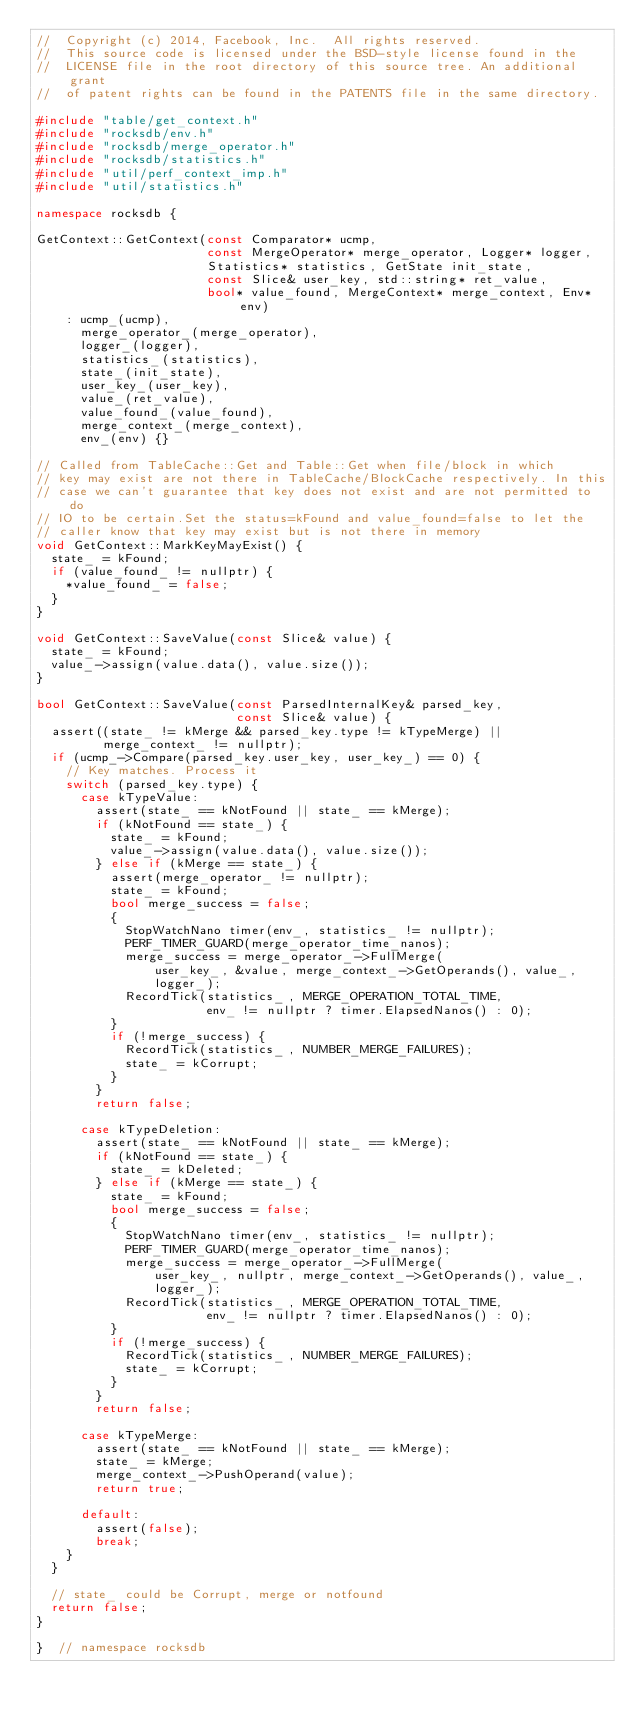Convert code to text. <code><loc_0><loc_0><loc_500><loc_500><_C++_>//  Copyright (c) 2014, Facebook, Inc.  All rights reserved.
//  This source code is licensed under the BSD-style license found in the
//  LICENSE file in the root directory of this source tree. An additional grant
//  of patent rights can be found in the PATENTS file in the same directory.

#include "table/get_context.h"
#include "rocksdb/env.h"
#include "rocksdb/merge_operator.h"
#include "rocksdb/statistics.h"
#include "util/perf_context_imp.h"
#include "util/statistics.h"

namespace rocksdb {

GetContext::GetContext(const Comparator* ucmp,
                       const MergeOperator* merge_operator, Logger* logger,
                       Statistics* statistics, GetState init_state,
                       const Slice& user_key, std::string* ret_value,
                       bool* value_found, MergeContext* merge_context, Env* env)
    : ucmp_(ucmp),
      merge_operator_(merge_operator),
      logger_(logger),
      statistics_(statistics),
      state_(init_state),
      user_key_(user_key),
      value_(ret_value),
      value_found_(value_found),
      merge_context_(merge_context),
      env_(env) {}

// Called from TableCache::Get and Table::Get when file/block in which
// key may exist are not there in TableCache/BlockCache respectively. In this
// case we can't guarantee that key does not exist and are not permitted to do
// IO to be certain.Set the status=kFound and value_found=false to let the
// caller know that key may exist but is not there in memory
void GetContext::MarkKeyMayExist() {
  state_ = kFound;
  if (value_found_ != nullptr) {
    *value_found_ = false;
  }
}

void GetContext::SaveValue(const Slice& value) {
  state_ = kFound;
  value_->assign(value.data(), value.size());
}

bool GetContext::SaveValue(const ParsedInternalKey& parsed_key,
                           const Slice& value) {
  assert((state_ != kMerge && parsed_key.type != kTypeMerge) ||
         merge_context_ != nullptr);
  if (ucmp_->Compare(parsed_key.user_key, user_key_) == 0) {
    // Key matches. Process it
    switch (parsed_key.type) {
      case kTypeValue:
        assert(state_ == kNotFound || state_ == kMerge);
        if (kNotFound == state_) {
          state_ = kFound;
          value_->assign(value.data(), value.size());
        } else if (kMerge == state_) {
          assert(merge_operator_ != nullptr);
          state_ = kFound;
          bool merge_success = false;
          {
            StopWatchNano timer(env_, statistics_ != nullptr);
            PERF_TIMER_GUARD(merge_operator_time_nanos);
            merge_success = merge_operator_->FullMerge(
                user_key_, &value, merge_context_->GetOperands(), value_,
                logger_);
            RecordTick(statistics_, MERGE_OPERATION_TOTAL_TIME,
                       env_ != nullptr ? timer.ElapsedNanos() : 0);
          }
          if (!merge_success) {
            RecordTick(statistics_, NUMBER_MERGE_FAILURES);
            state_ = kCorrupt;
          }
        }
        return false;

      case kTypeDeletion:
        assert(state_ == kNotFound || state_ == kMerge);
        if (kNotFound == state_) {
          state_ = kDeleted;
        } else if (kMerge == state_) {
          state_ = kFound;
          bool merge_success = false;
          {
            StopWatchNano timer(env_, statistics_ != nullptr);
            PERF_TIMER_GUARD(merge_operator_time_nanos);
            merge_success = merge_operator_->FullMerge(
                user_key_, nullptr, merge_context_->GetOperands(), value_,
                logger_);
            RecordTick(statistics_, MERGE_OPERATION_TOTAL_TIME,
                       env_ != nullptr ? timer.ElapsedNanos() : 0);
          }
          if (!merge_success) {
            RecordTick(statistics_, NUMBER_MERGE_FAILURES);
            state_ = kCorrupt;
          }
        }
        return false;

      case kTypeMerge:
        assert(state_ == kNotFound || state_ == kMerge);
        state_ = kMerge;
        merge_context_->PushOperand(value);
        return true;

      default:
        assert(false);
        break;
    }
  }

  // state_ could be Corrupt, merge or notfound
  return false;
}

}  // namespace rocksdb
</code> 